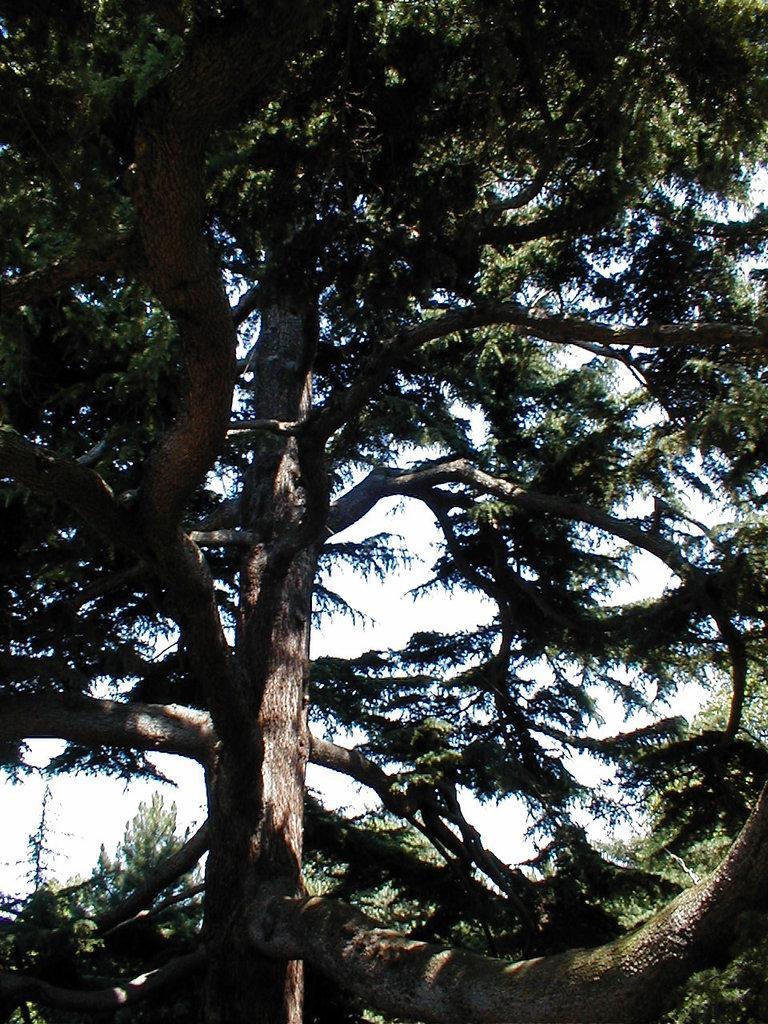In one or two sentences, can you explain what this image depicts? In this picture there are trees around the area of the image. 